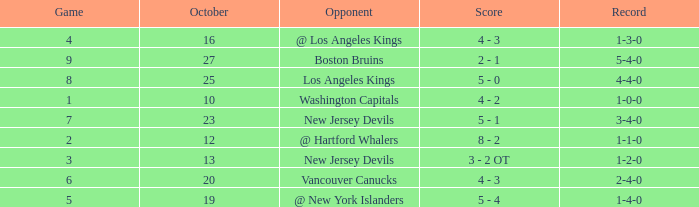Parse the table in full. {'header': ['Game', 'October', 'Opponent', 'Score', 'Record'], 'rows': [['4', '16', '@ Los Angeles Kings', '4 - 3', '1-3-0'], ['9', '27', 'Boston Bruins', '2 - 1', '5-4-0'], ['8', '25', 'Los Angeles Kings', '5 - 0', '4-4-0'], ['1', '10', 'Washington Capitals', '4 - 2', '1-0-0'], ['7', '23', 'New Jersey Devils', '5 - 1', '3-4-0'], ['2', '12', '@ Hartford Whalers', '8 - 2', '1-1-0'], ['3', '13', 'New Jersey Devils', '3 - 2 OT', '1-2-0'], ['6', '20', 'Vancouver Canucks', '4 - 3', '2-4-0'], ['5', '19', '@ New York Islanders', '5 - 4', '1-4-0']]} What was the average game with a record of 4-4-0? 8.0. 